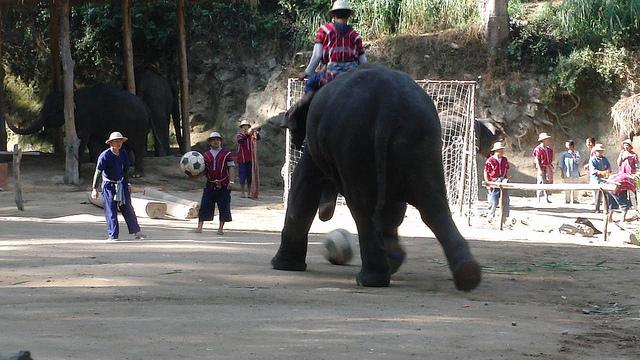What is the elephant doing with the ball?

Choices:
A) destroying it
B) eating it
C) kicking it
D) throwing it kicking it 